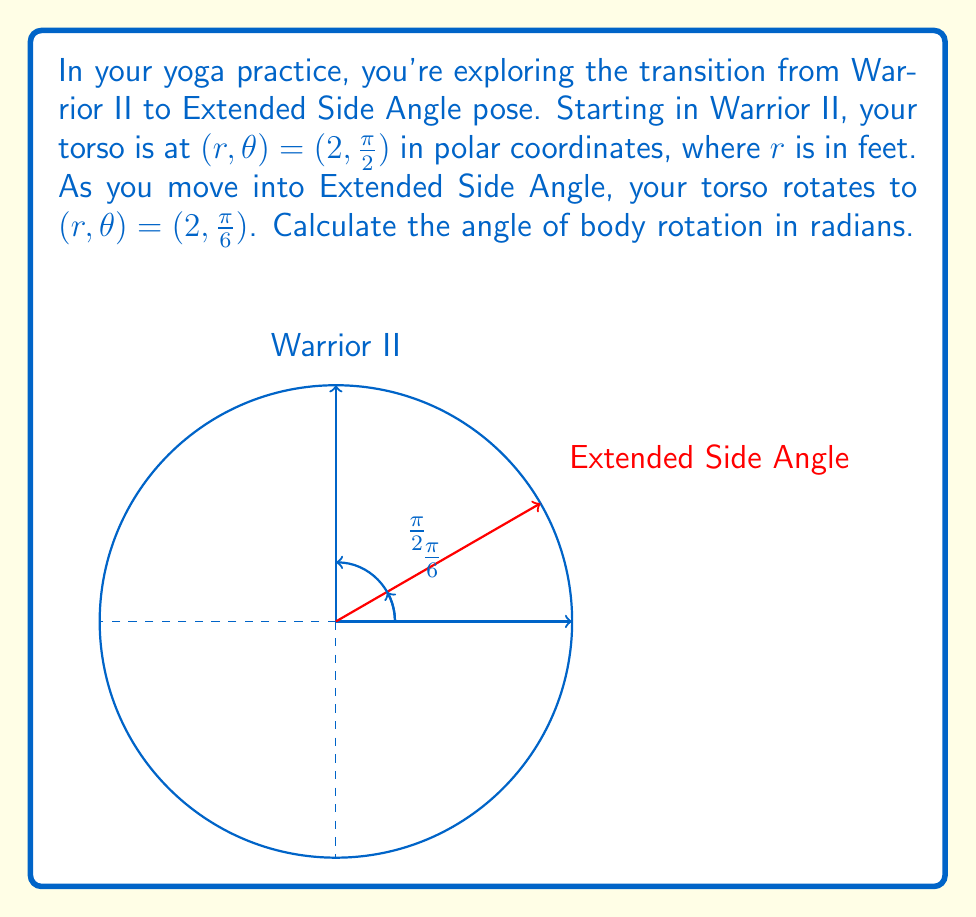Can you solve this math problem? Let's approach this step-by-step:

1) In polar coordinates, the angle $\theta$ is measured counterclockwise from the positive x-axis.

2) The initial position (Warrior II) is at $\theta_1 = \frac{\pi}{2}$ radians.

3) The final position (Extended Side Angle) is at $\theta_2 = \frac{\pi}{6}$ radians.

4) To find the angle of rotation, we need to calculate the difference between these angles:

   $$\text{Rotation angle} = \theta_1 - \theta_2$$

5) Substituting the values:

   $$\text{Rotation angle} = \frac{\pi}{2} - \frac{\pi}{6}$$

6) To subtract fractions with different denominators, we need to find a common denominator:

   $$\text{Rotation angle} = \frac{3\pi}{6} - \frac{\pi}{6} = \frac{2\pi}{6}$$

7) Simplify:

   $$\text{Rotation angle} = \frac{\pi}{3} \text{ radians}$$

Note: The rotation is clockwise, which is why we subtracted $\theta_2$ from $\theta_1$.
Answer: $\frac{\pi}{3}$ radians 